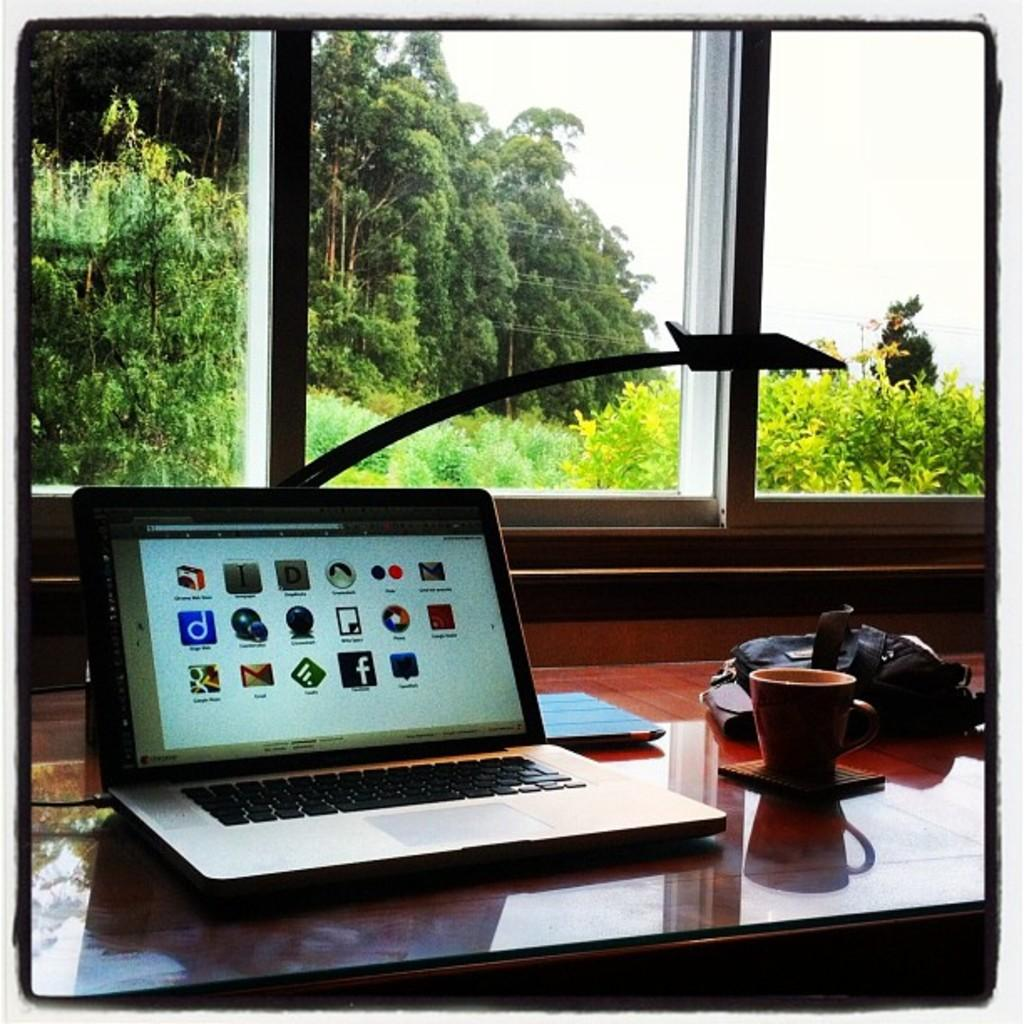What electronic device is on the table in the image? There is a laptop on the table in the image. What else is on the table besides the laptop? There is a cup and a bag on the table. What can be seen in the background of the image? There are trees and the sky visible in the background of the image. What type of wire can be seen connecting the laptop to the trees in the image? There is no wire connecting the laptop to the trees in the image. 